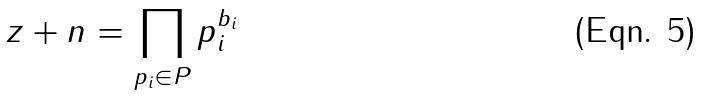<formula> <loc_0><loc_0><loc_500><loc_500>z + n = \prod _ { p _ { i } \in P } p _ { i } ^ { b _ { i } }</formula> 